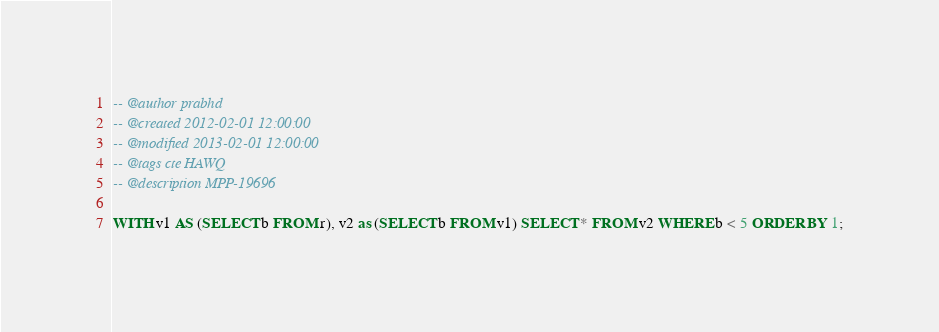<code> <loc_0><loc_0><loc_500><loc_500><_SQL_>-- @author prabhd
-- @created 2012-02-01 12:00:00
-- @modified 2013-02-01 12:00:00
-- @tags cte HAWQ
-- @description MPP-19696

WITH v1 AS (SELECT b FROM r), v2 as (SELECT b FROM v1) SELECT * FROM v2 WHERE b < 5 ORDER BY 1;
</code> 